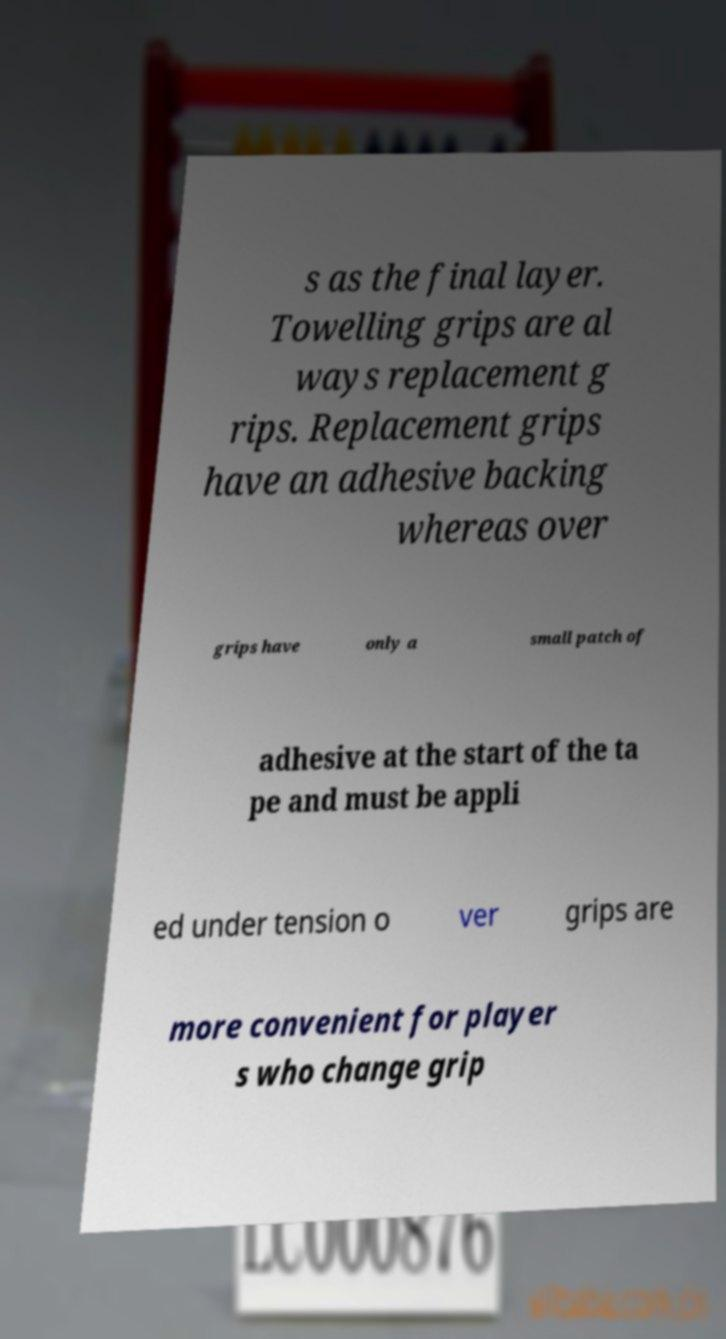Could you assist in decoding the text presented in this image and type it out clearly? s as the final layer. Towelling grips are al ways replacement g rips. Replacement grips have an adhesive backing whereas over grips have only a small patch of adhesive at the start of the ta pe and must be appli ed under tension o ver grips are more convenient for player s who change grip 